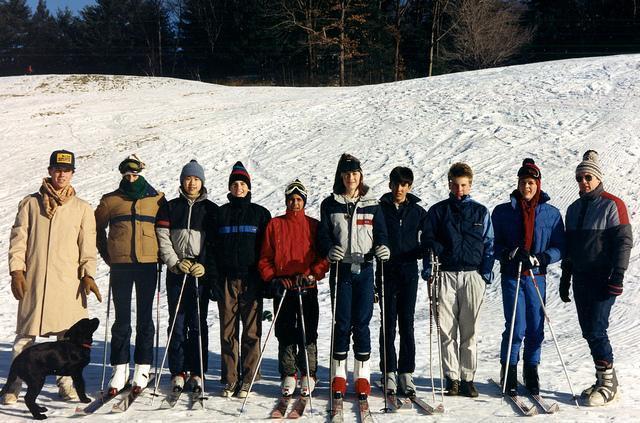How many people can be seen?
Give a very brief answer. 10. How many chairs are in the scene?
Give a very brief answer. 0. 